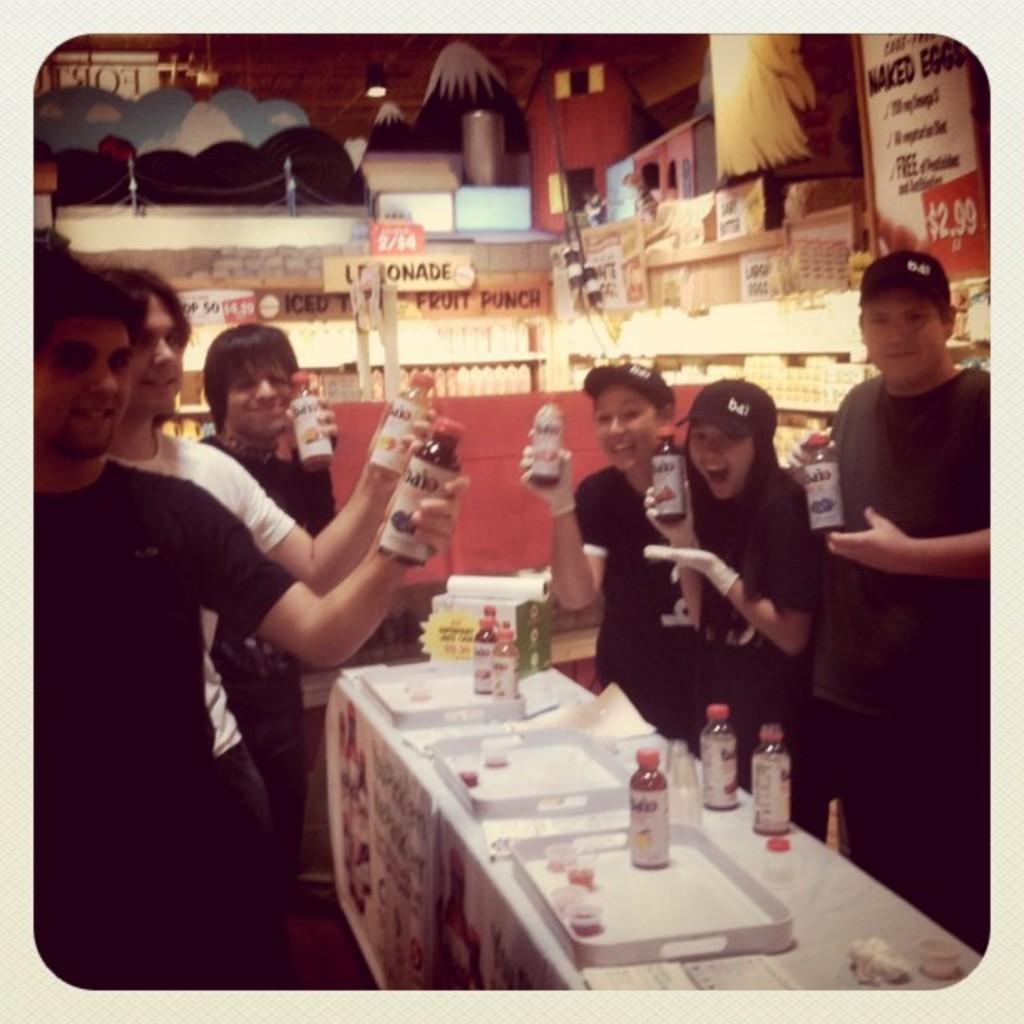How would you summarize this image in a sentence or two? In this image there are few people standing and holding a bottle in their hands. There are few bottles and trays placed on the table. In the background we can see few things on the wall. 